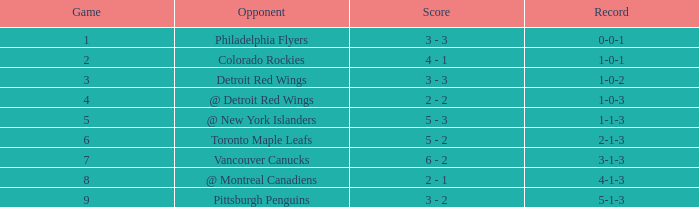Name the least game for record of 1-0-2 3.0. 